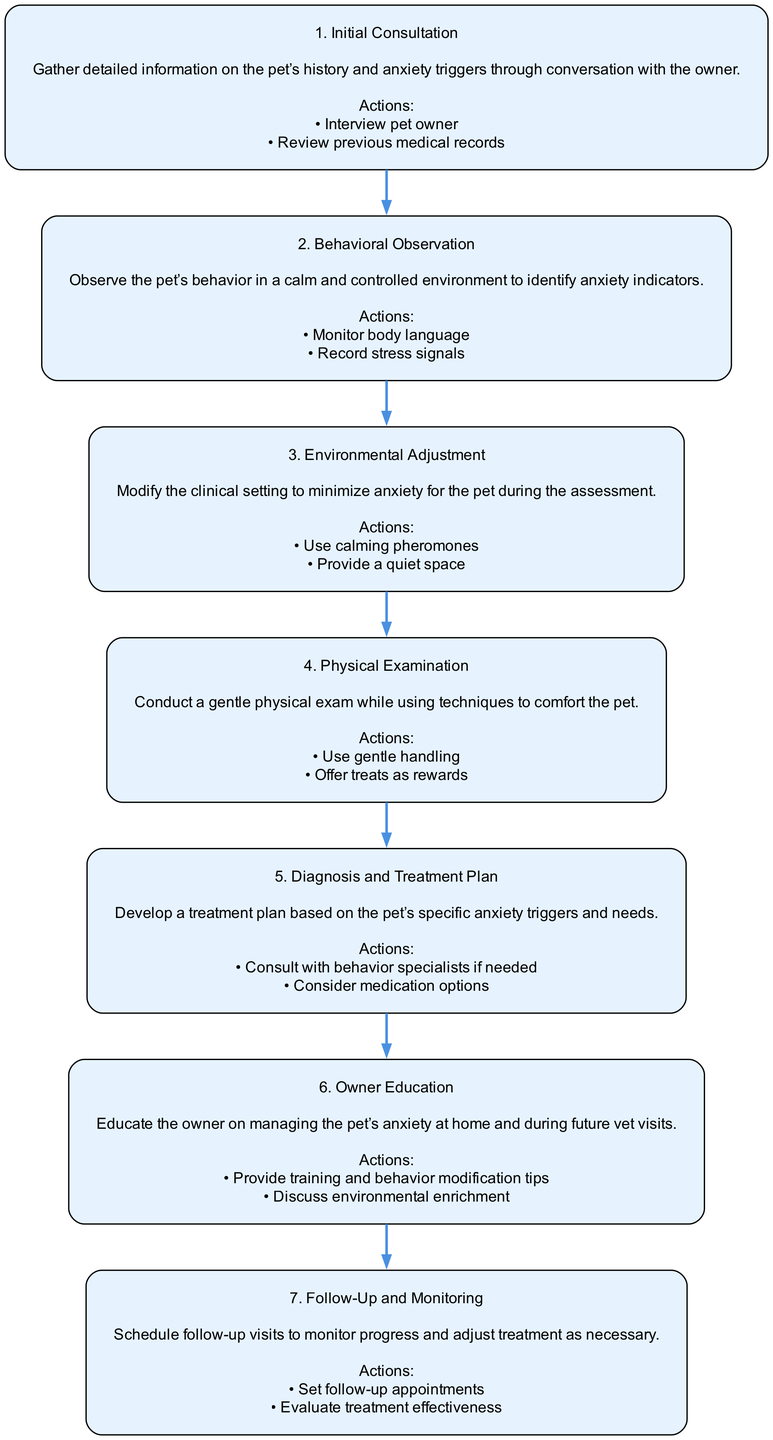What is the first step in the process? The first step listed in the diagram is "Initial Consultation," which is labeled as step 1.
Answer: Initial Consultation How many primary steps are shown in the diagram? There are seven steps outlined in the process for assessing and treating anxious pets.
Answer: 7 What actions are taken during the "Behavioral Observation"? The actions listed for this step include "Monitor body language" and "Record stress signals."
Answer: Monitor body language, Record stress signals Which step directly precedes "Diagnosis and Treatment Plan"? The step that directly precedes "Diagnosis and Treatment Plan" is "Physical Examination," labeled as step 4.
Answer: Physical Examination What is the purpose of the "Environmental Adjustment" step? The purpose is to modify the clinical setting to minimize anxiety for the pet during the assessment.
Answer: Modify the clinical setting What actions are included in the "Owner Education" step? The actions include "Provide training and behavior modification tips" and "Discuss environmental enrichment."
Answer: Provide training and behavior modification tips, Discuss environmental enrichment Which step involves scheduling follow-up visits? The step that involves this action is "Follow-Up and Monitoring," which is the last step.
Answer: Follow-Up and Monitoring What should be consulted if needed during the "Diagnosis and Treatment Plan"? It suggests that "Consult with behavior specialists if needed" is a necessary action during this step.
Answer: Consult with behavior specialists if needed What is the main focus of the "Initial Consultation"? The main focus is to gather detailed information on the pet’s history and anxiety triggers through conversation with the owner.
Answer: Gather detailed information on the pet’s history and anxiety triggers 